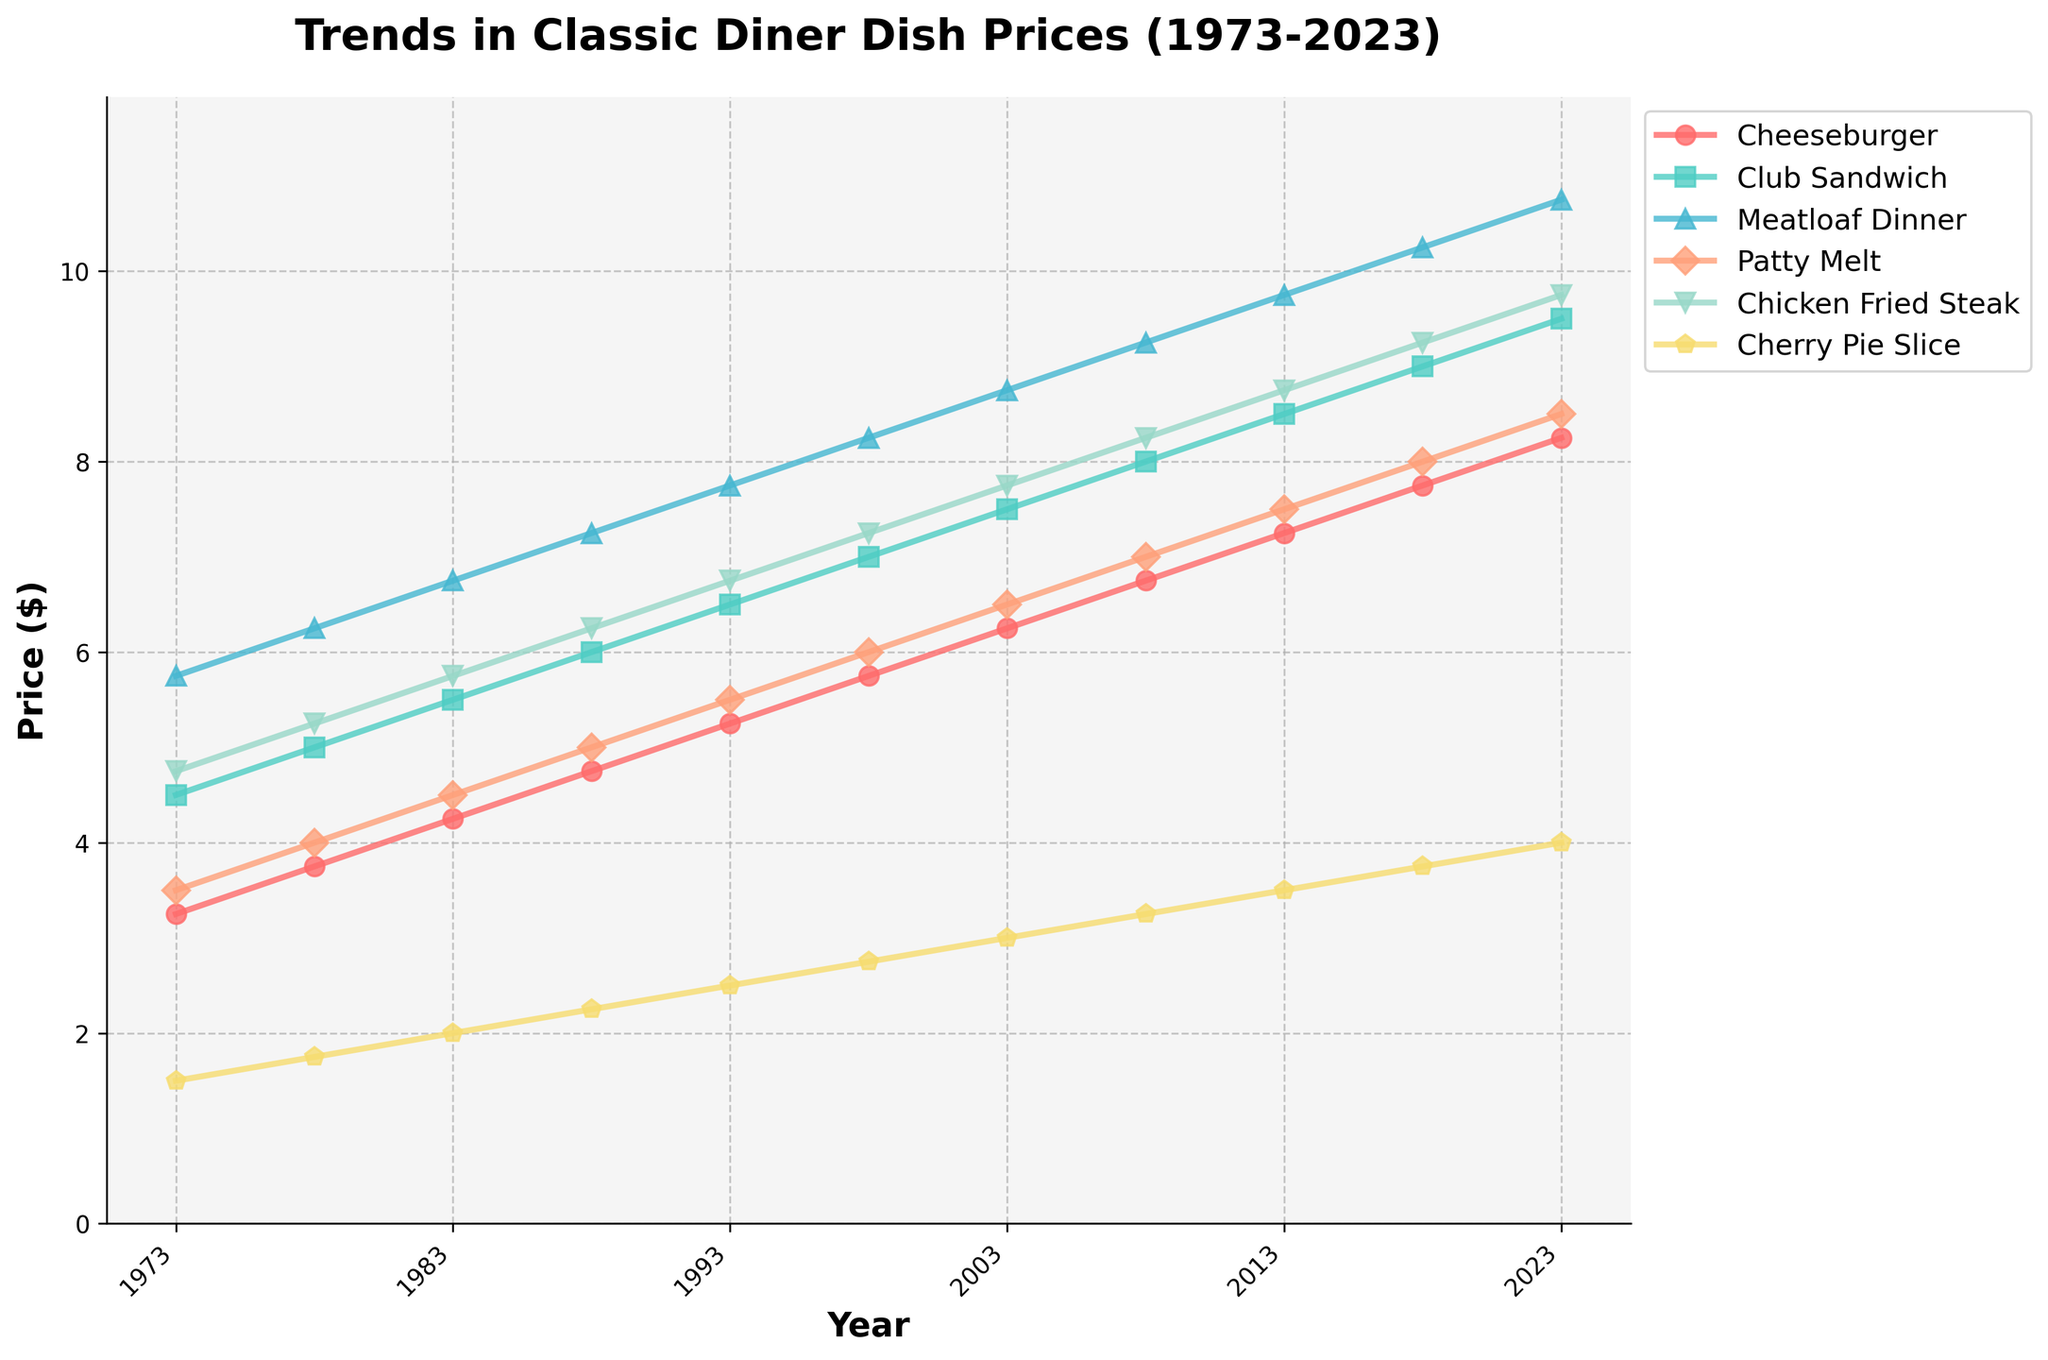What was the price of a Cheeseburger in 2003? The line representing Cheeseburger in the figure shows a data point corresponding to the year 2003. By tracing horizontally from the year 2003 up to the Cheeseburger line, we find the price.
Answer: $6.25 Which dish had the greatest price increase from 1973 to 2023? To determine this, we look at the starting prices in 1973 and the ending prices in 2023 for all dishes. Calculate the differences for each dish and identify the highest difference. Cheeseburger: 8.25 - 3.25 = 5.00; Club Sandwich: 9.50 - 4.50 = 5.00; Meatloaf Dinner: 10.75 - 5.75 = 5.00; Patty Melt: 8.50 - 3.50 = 5.00; Chicken Fried Steak: 9.75 - 4.75 = 5.00; Cherry Pie Slice: 4.00 - 1.50 = 2.50.
Answer: All savory dishes increased by $5.00 Did the price of the Patty Melt surpass that of the Club Sandwich at any point between 1973 and 2023? By visually comparing the Patty Melt line and the Club Sandwich line over the years, we see if the Patty Melt line crosses above the Club Sandwich line at any point.
Answer: No What is the average price of a Cherry Pie Slice over the 50-year period? Identify the prices of the Cherry Pie Slice at each year listed: (1.50, 1.75, 2.00, 2.25, 2.50, 2.75, 3.00, 3.25, 3.50, 3.75, 4.00). Sum these prices and divide by the number of points (11). (1.50 + 1.75 + 2.00 + 2.25 + 2.50 + 2.75 + 3.00 + 3.25 + 3.50 + 3.75 + 4.00) / 11.
Answer: $2.95 Between 1983 and 1998, which dish saw the smallest increase in price? Look at the prices for each dish in 1983 and 1998 and calculate the difference. Cheeseburger: 5.75 - 4.25 = 1.50; Club Sandwich: 7.00 - 5.50 = 1.50; Meatloaf Dinner: 8.25 - 6.75 = 1.50; Patty Melt: 6.00 - 4.50 = 1.50; Chicken Fried Steak: 7.25 - 5.75 = 1.50; Cherry Pie Slice: 2.75 - 2.00 = 0.75. Cherry Pie Slice saw the smallest increase.
Answer: Cherry Pie Slice In what year did the price of a Chicken Fried Steak first reach $9? Track the line representing Chicken Fried Steak and find the first year it reaches or exceeds $9 by looking at the Y-axis and visually matching.
Answer: 2018 What is the combined price of a Cheeseburger, a Club Sandwich, and a slice of Cherry Pie in 2023? Look at the prices of these items in 2023 and sum them up: Cheeseburger: $8.25, Club Sandwich: $9.50, Cherry Pie Slice: $4.00. Add these values together. 8.25 + 9.50 + 4.00 = 21.75.
Answer: $21.75 Which dish had the most consistent price increase over the years? To identify the most consistent price increase, examine the slopes of the lines for each dish. The dish with the straightest, least fluctuating upward slope indicates consistency.
Answer: Cheeseburger How much did the price of a Meatloaf Dinner increase between 1993 and 2018? Find the prices for a Meatloaf Dinner in 1993 and 2018. Subtract the 1993 price from the 2018 price: 10.25 - 7.75 = 2.50.
Answer: $2.50 Was there any year where the price of the Cherry Pie Slice declined from the previous year? Review the trends of the Cherry Pie Slice prices year by year. No line segment for the Cherry Pie Slice should trend downward.
Answer: No 